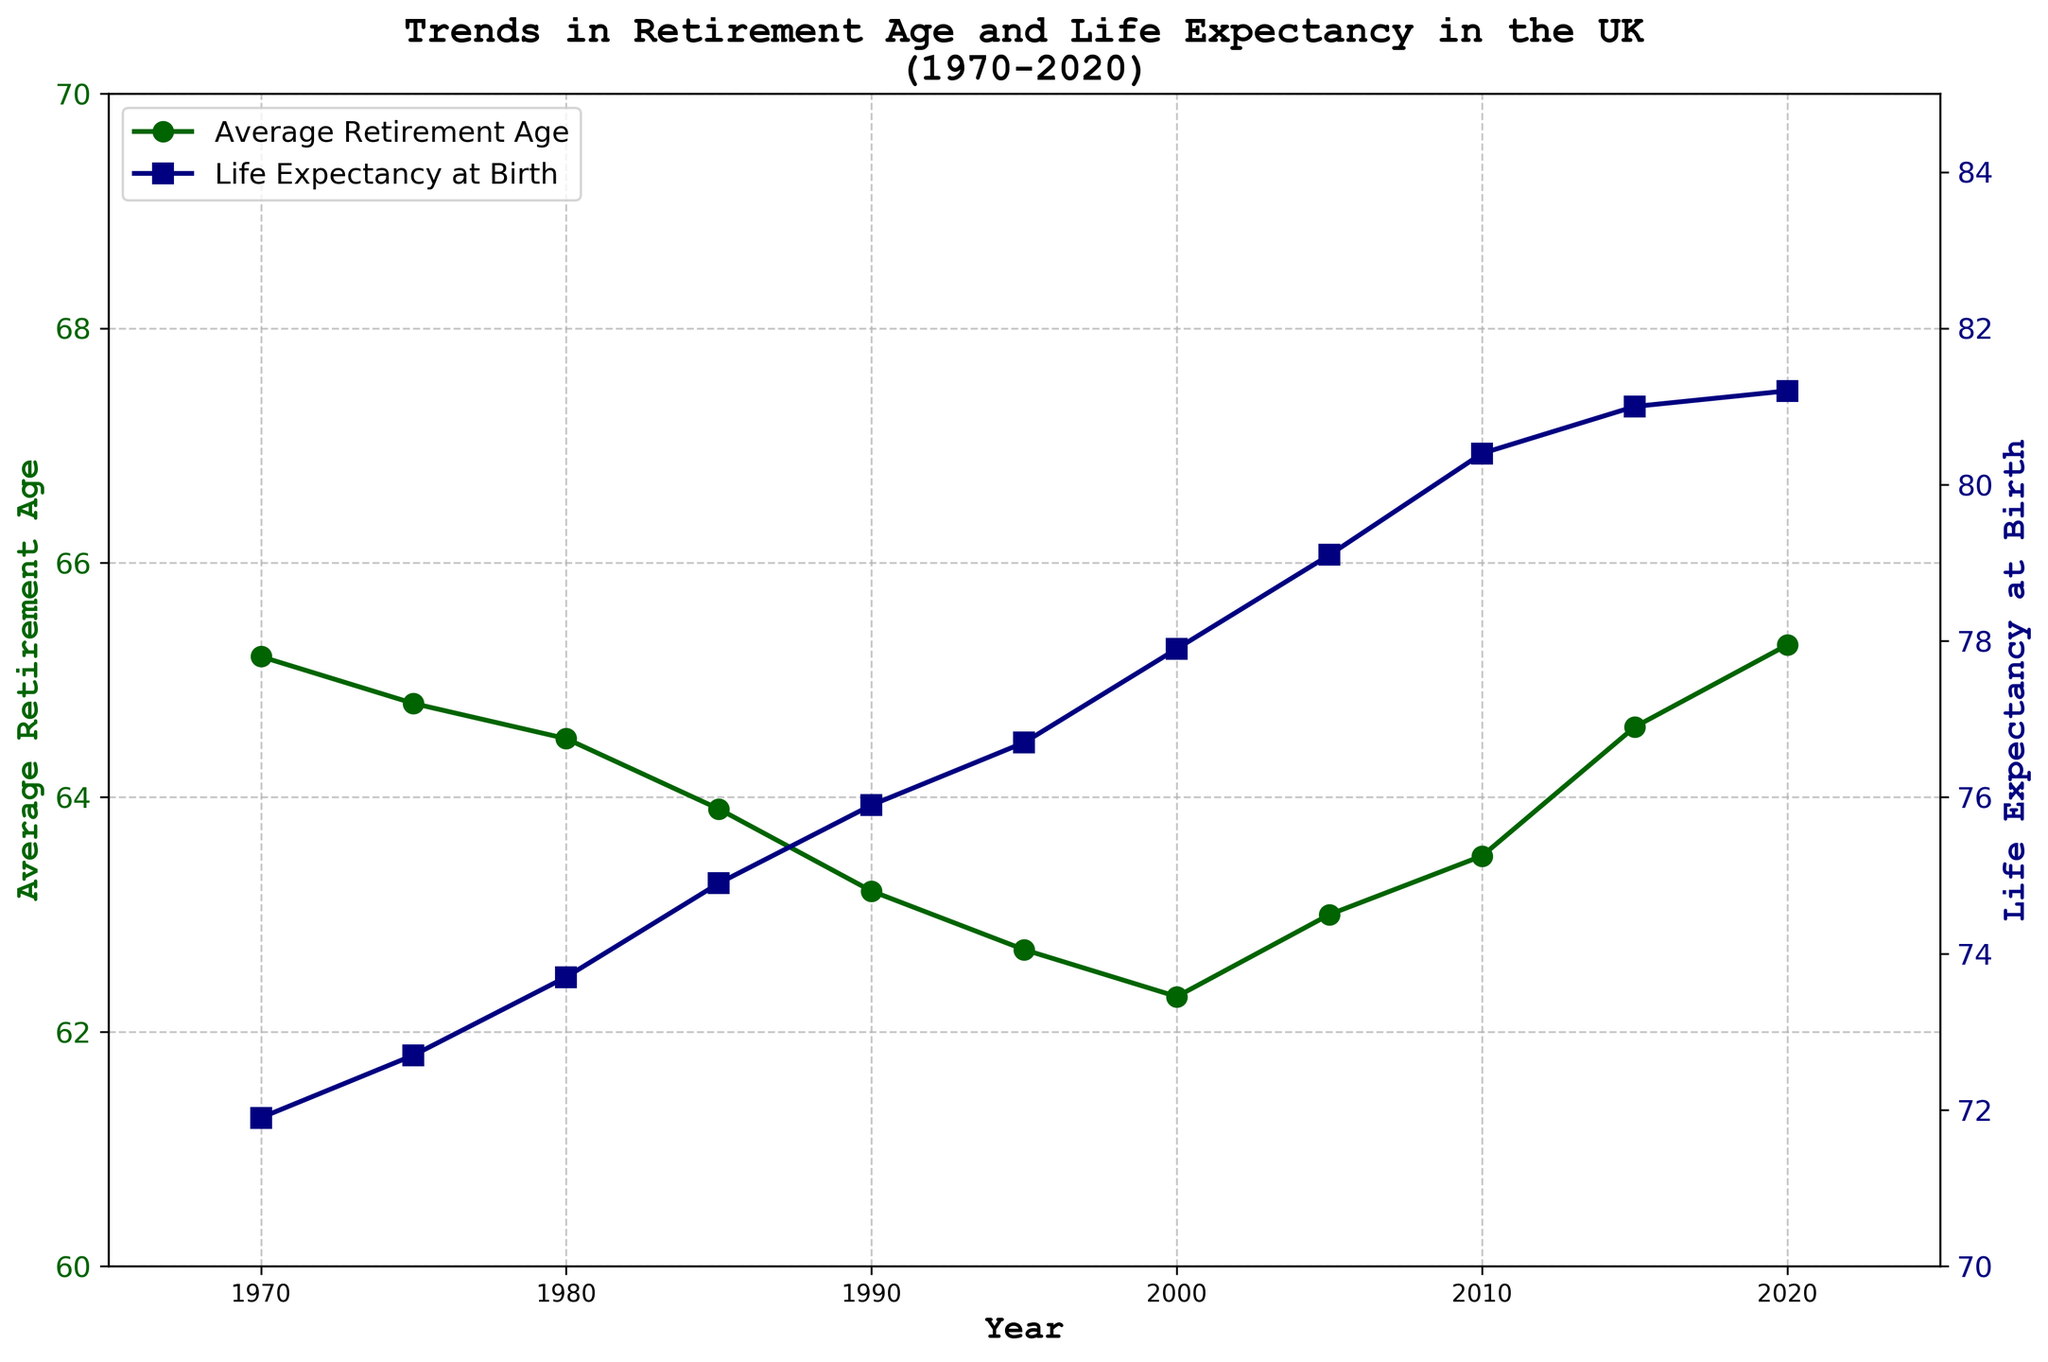What is the highest average retirement age between 1970 and 2020? Locate the peak point on the green line which represents the average retirement age. The highest value is at 2020 with a value of 65.3.
Answer: 65.3 Between 1985 and 1995, how did the life expectancy at birth change? Refer to the blue line from 1985 to 1995. In 1985, life expectancy was 74.9, and in 1995 it was 76.7. The difference is 76.7 - 74.9 = 1.8 years.
Answer: Increased by 1.8 years What is the difference in life expectancy at birth between 1970 and 2020? Refer to the blue line at the years 1970 and 2020. The values are 71.9 and 81.2 respectively. The difference is 81.2 - 71.9 = 9.3 years.
Answer: 9.3 years Which year shows the lowest average retirement age and what is the value? Locate the lowest point on the green line which represents the average retirement age. The lowest value is at 2000 with a value of 62.3.
Answer: 2000, 62.3 Compare the trend in average retirement age to life expectancy at birth. Are they generally moving in the same direction? Observe both the green and blue lines over time. Notice that while life expectancy consistently increases, the retirement age initially decreases and then increases again.
Answer: No, not always In which decade did the average retirement age decrease the most? Observe the green line for sharp declines. The most significant drop is between 1980 and 1990 where it drops roughly from 64.5 to 63.2, a drop of 1.3 years.
Answer: 1980-1990 What was the average retirement age in 2015, and how does it compare to that in 1970? Find the values on the green line for 2015 and 1970. The values are 64.6 and 65.2 respectively. The difference is 65.2 - 64.6 = 0.6 years.
Answer: 2015: 64.6, 0.6 years lower than 1970 How did life expectancy change from 2000 to 2010? Refer to the blue line for years 2000 and 2010. The values are 77.9 and 80.4 respectively. The difference is 80.4 - 77.9 = 2.5 years.
Answer: Increased by 2.5 years Identify a year where both the average retirement age and life expectancy saw an increase from the previous year. Examine both lines; one such period is from 2005 to 2010. Both metrics show an increase from previous values.
Answer: 2010 What's the range of life expectancy at birth from 1970 to 2020? Find the minimum and maximum values on the blue line. The minimum is 71.9 (1970) and the maximum is 81.2 (2020). The range is 81.2 - 71.9 = 9.3 years.
Answer: 9.3 years 